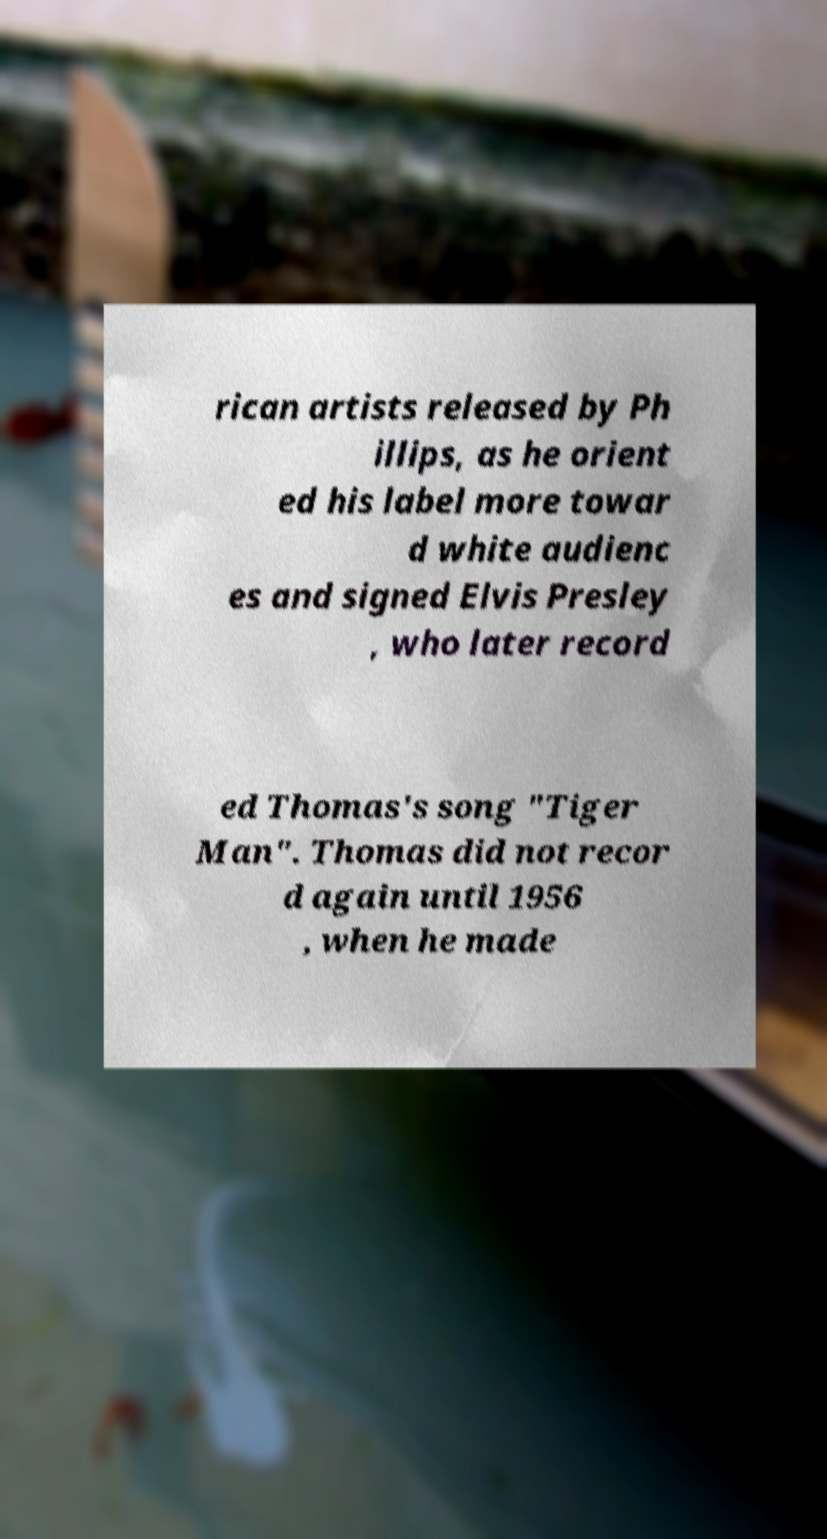I need the written content from this picture converted into text. Can you do that? rican artists released by Ph illips, as he orient ed his label more towar d white audienc es and signed Elvis Presley , who later record ed Thomas's song "Tiger Man". Thomas did not recor d again until 1956 , when he made 